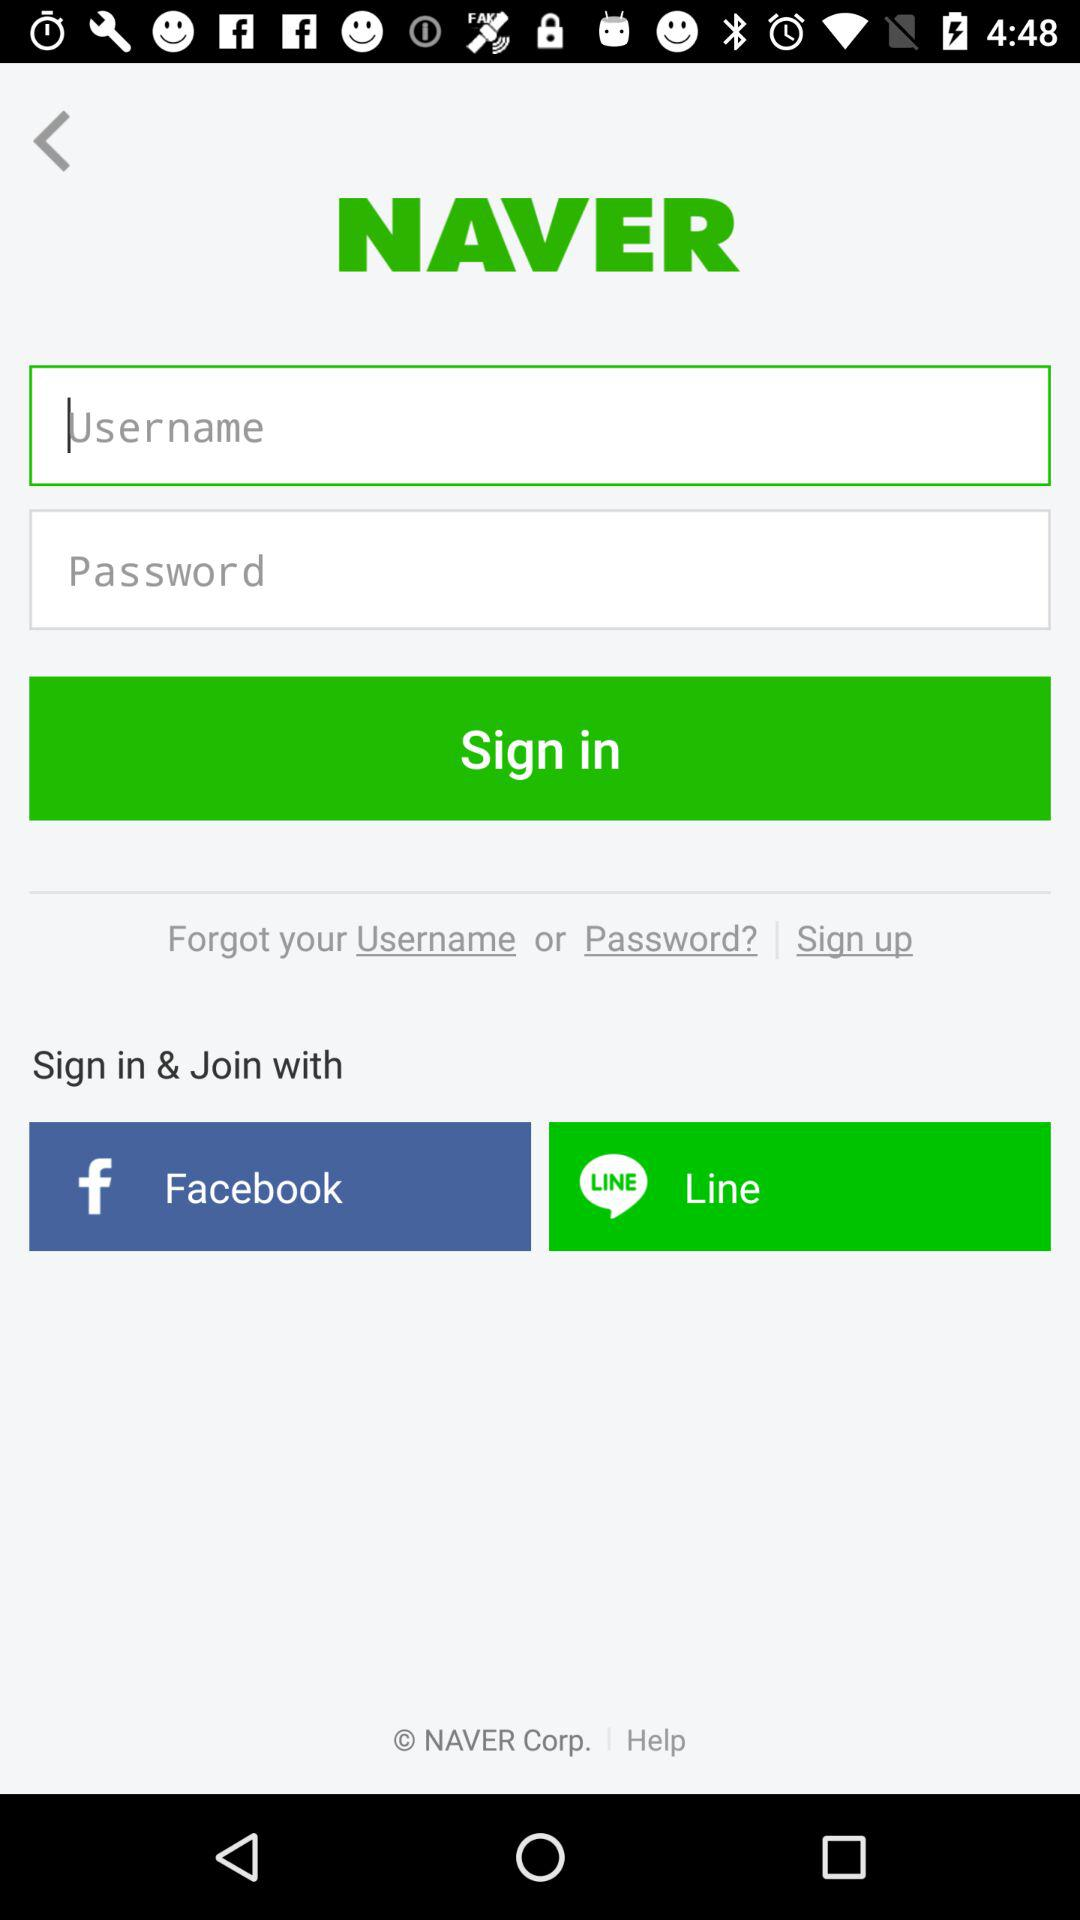What are the options to sign in? The options are "Facebook" and "Line". 